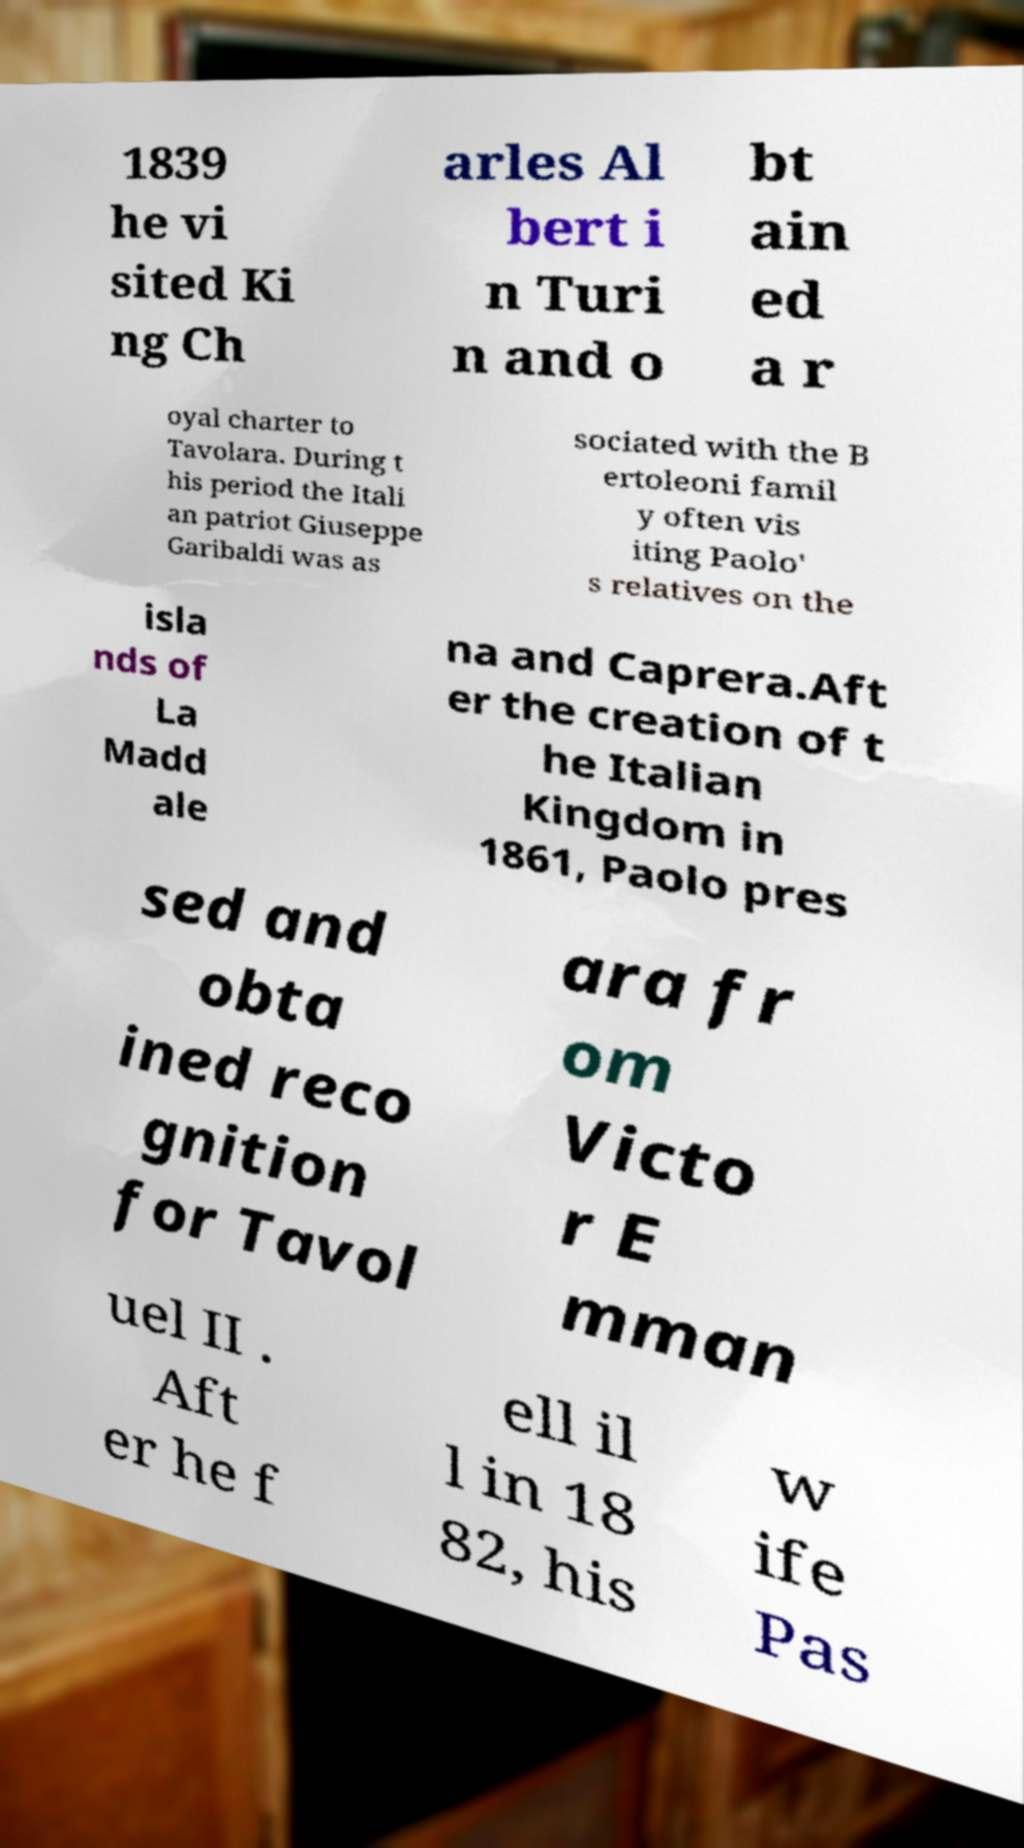There's text embedded in this image that I need extracted. Can you transcribe it verbatim? 1839 he vi sited Ki ng Ch arles Al bert i n Turi n and o bt ain ed a r oyal charter to Tavolara. During t his period the Itali an patriot Giuseppe Garibaldi was as sociated with the B ertoleoni famil y often vis iting Paolo' s relatives on the isla nds of La Madd ale na and Caprera.Aft er the creation of t he Italian Kingdom in 1861, Paolo pres sed and obta ined reco gnition for Tavol ara fr om Victo r E mman uel II . Aft er he f ell il l in 18 82, his w ife Pas 